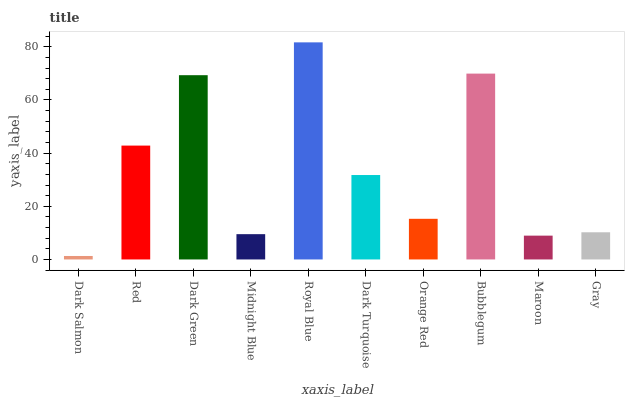Is Dark Salmon the minimum?
Answer yes or no. Yes. Is Royal Blue the maximum?
Answer yes or no. Yes. Is Red the minimum?
Answer yes or no. No. Is Red the maximum?
Answer yes or no. No. Is Red greater than Dark Salmon?
Answer yes or no. Yes. Is Dark Salmon less than Red?
Answer yes or no. Yes. Is Dark Salmon greater than Red?
Answer yes or no. No. Is Red less than Dark Salmon?
Answer yes or no. No. Is Dark Turquoise the high median?
Answer yes or no. Yes. Is Orange Red the low median?
Answer yes or no. Yes. Is Red the high median?
Answer yes or no. No. Is Dark Salmon the low median?
Answer yes or no. No. 